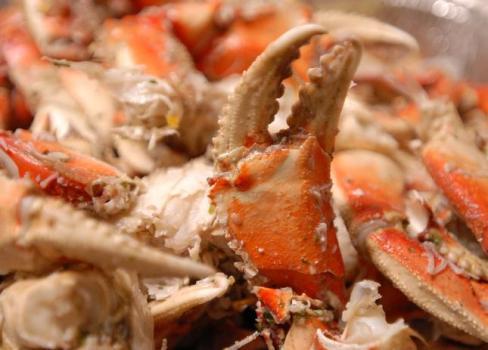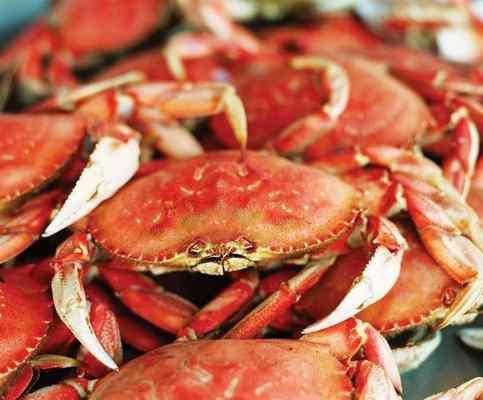The first image is the image on the left, the second image is the image on the right. Examine the images to the left and right. Is the description "There are at least 8 upside crabs revealing there what soft part underneath." accurate? Answer yes or no. No. The first image is the image on the left, the second image is the image on the right. Examine the images to the left and right. Is the description "One image includes a camera-facing crab with at least one front claw raised and the edge of a red container behind it." accurate? Answer yes or no. No. 